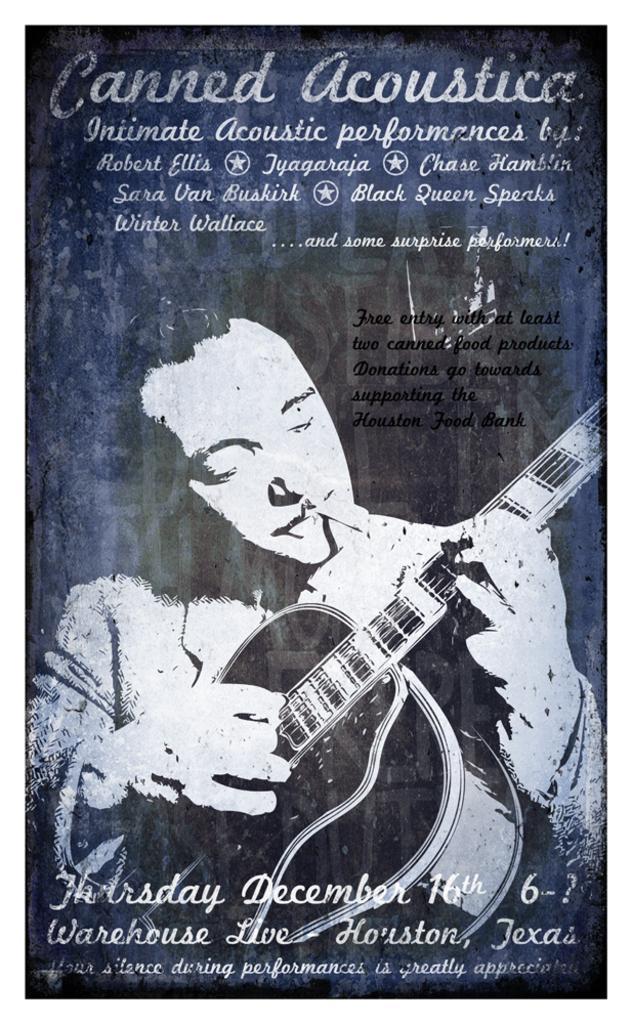Please provide a concise description of this image. This is the picture of the poster. In this picture, we see a man is holding a guitar and he might be playing the guitar. At the bottom and at the top, we see some text written. In the background, it is blue in color. 